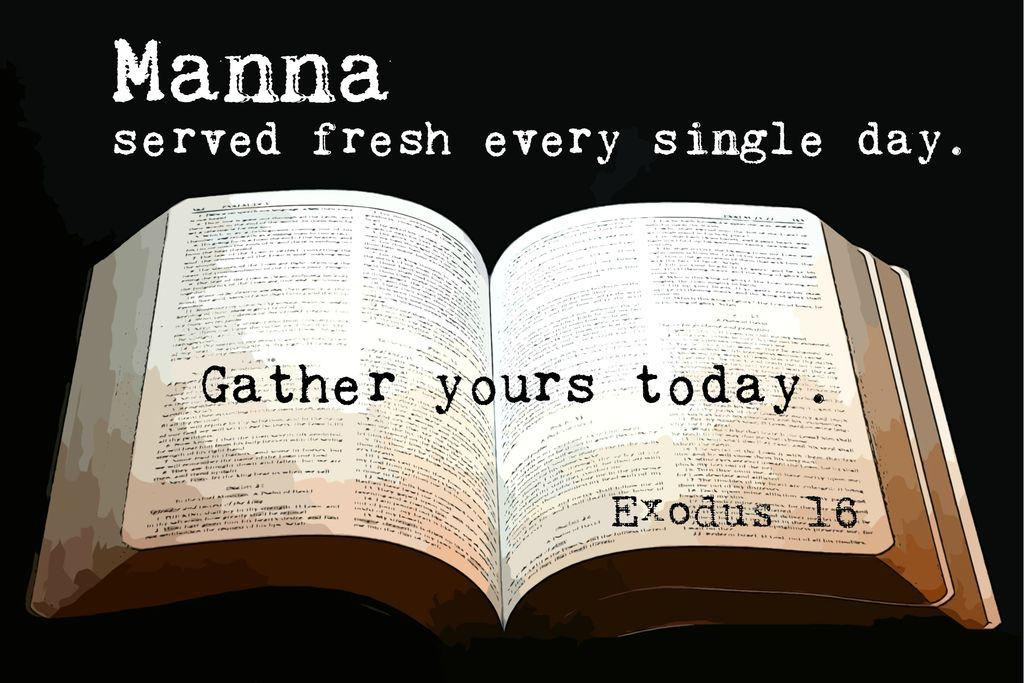Provide a one-sentence caption for the provided image. A bible is opened with "Gather yours today, Exodus 16.". 